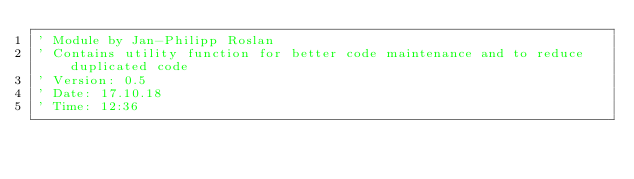Convert code to text. <code><loc_0><loc_0><loc_500><loc_500><_VisualBasic_>' Module by Jan-Philipp Roslan
' Contains utility function for better code maintenance and to reduce duplicated code
' Version: 0.5
' Date: 17.10.18
' Time: 12:36

</code> 